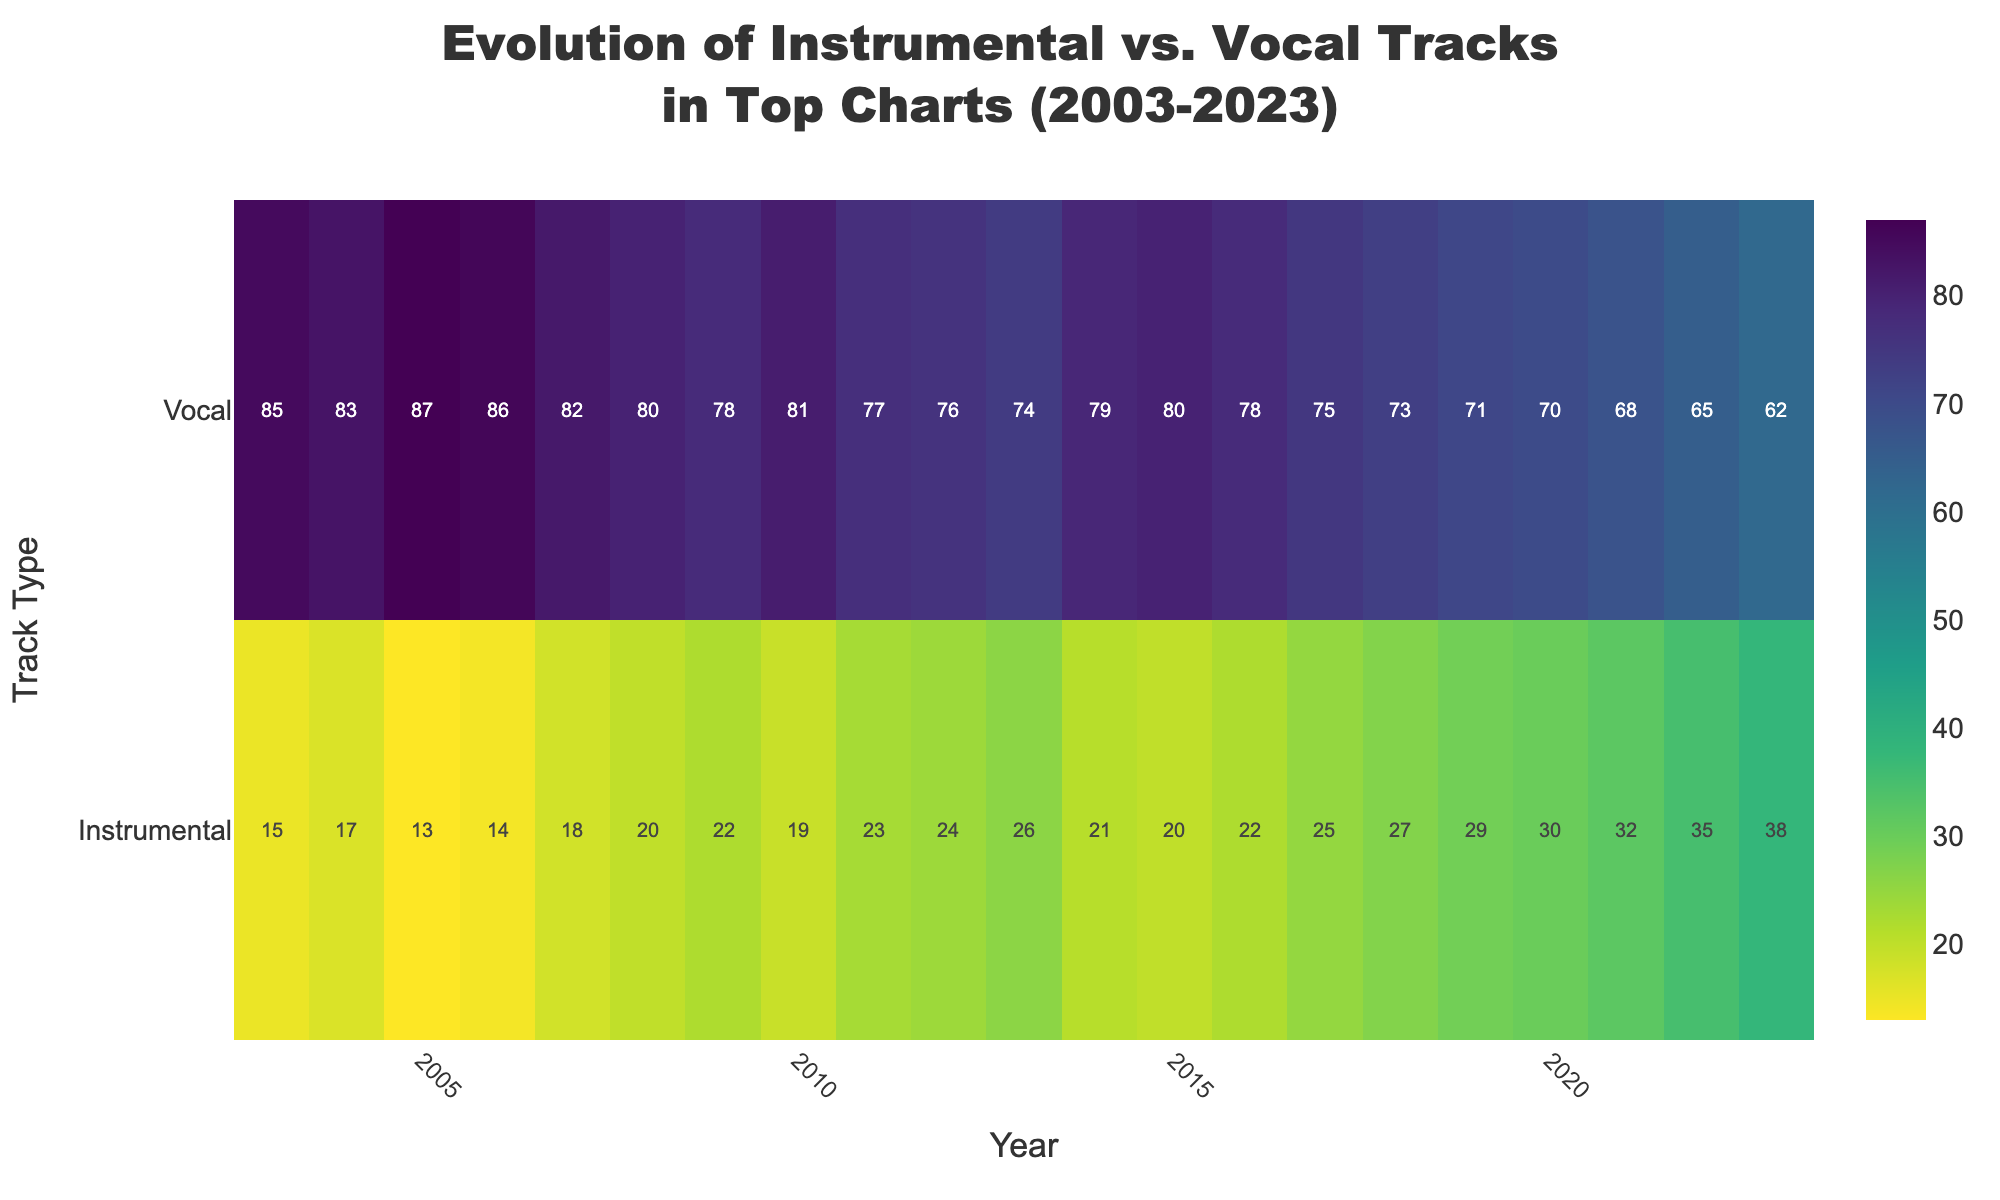What does the title of the heatmap indicate? The title of the heatmap is "Evolution of Instrumental vs. Vocal Tracks in Top Charts (2003-2023)" which indicates that the heatmap shows how the percentage of instrumental and vocal tracks in the top charts has changed over the last 20 years, from 2003 to 2023.
Answer: Evolution of Instrumental vs. Vocal Tracks in Top Charts (2003-2023) Which track type has a higher percentage in the top charts from 2003 to 2023? By looking at the heatmap, it can be observed that Vocal tracks consistently have a higher percentage compared to Instrumental tracks throughout the period from 2003 to 2023.
Answer: Vocal Tracks What is the percentage of Instrumental tracks in the year 2023? The heatmap shows that the percentage of Instrumental tracks in the year 2023 is 38%.
Answer: 38% Compare the trend of Instrumental tracks between 2003 and 2023. Did the percentage increase or decrease? By looking at the heatmap, we can see that the percentage of Instrumental tracks increased from 15% in 2003 to 38% in 2023.
Answer: Increased Calculate the average percentage of Vocal tracks over the entire period. To find the average, add up the percentages of Vocal tracks for each year and divide by the number of years (21). (85 + 83 + 87 + 86 + 82 + 80 + 78 + 81 + 77 + 76 + 74 + 79 + 80 + 78 + 75 + 73 + 71 + 70 + 68 + 65 + 62) / 21 = 78.
Answer: 78% By how much does the percentage of Instrumental tracks in 2023 differ from that in 2003? Subtract the percentage of Instrumental tracks in 2003 from that in 2023. 38% (2023) - 15% (2003) = 23%.
Answer: 23% Which year saw the highest percentage of Vocal tracks? By examining the heatmap, it can be observed that 2005 had the highest percentage of Vocal tracks at 87%.
Answer: 2005 During which year did the percentage of Instrumental tracks first exceed 30%? The heatmap indicates that the percentage of Instrumental tracks first exceeded 30% in the year 2020.
Answer: 2020 Can you see any distinct color patterns in the heatmap? What do they signify? The heatmap shows darker colors for lower percentages and lighter colors for higher percentages. Over the years, Instrumental tracks transition from darker to lighter shades, indicating an increasing trend, while Vocal tracks show the opposite trend.
Answer: Darker colors indicate lower percentages, lighter colors indicate higher percentages Between 2015 and 2020, which type of tracks had a more significant change in percentage? By comparing the heatmap values, we see that Instrumental tracks increased from 20% to 30% (a 10% change), while Vocal tracks decreased from 80% to 70% (also a 10% change). The change is equal between the two track types during this period.
Answer: Both had an equal change 